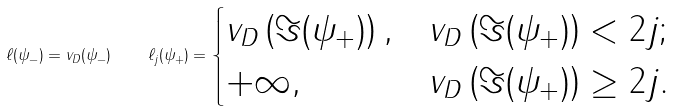Convert formula to latex. <formula><loc_0><loc_0><loc_500><loc_500>\ell ( \psi _ { - } ) = v _ { D } ( \psi _ { - } ) \quad \ell _ { j } ( \psi _ { + } ) = \begin{cases} v _ { D } \left ( \Im ( \psi _ { + } ) \right ) , & v _ { D } \left ( \Im ( \psi _ { + } ) \right ) < 2 j ; \\ + \infty , & v _ { D } \left ( \Im ( \psi _ { + } ) \right ) \geq 2 j . \end{cases}</formula> 